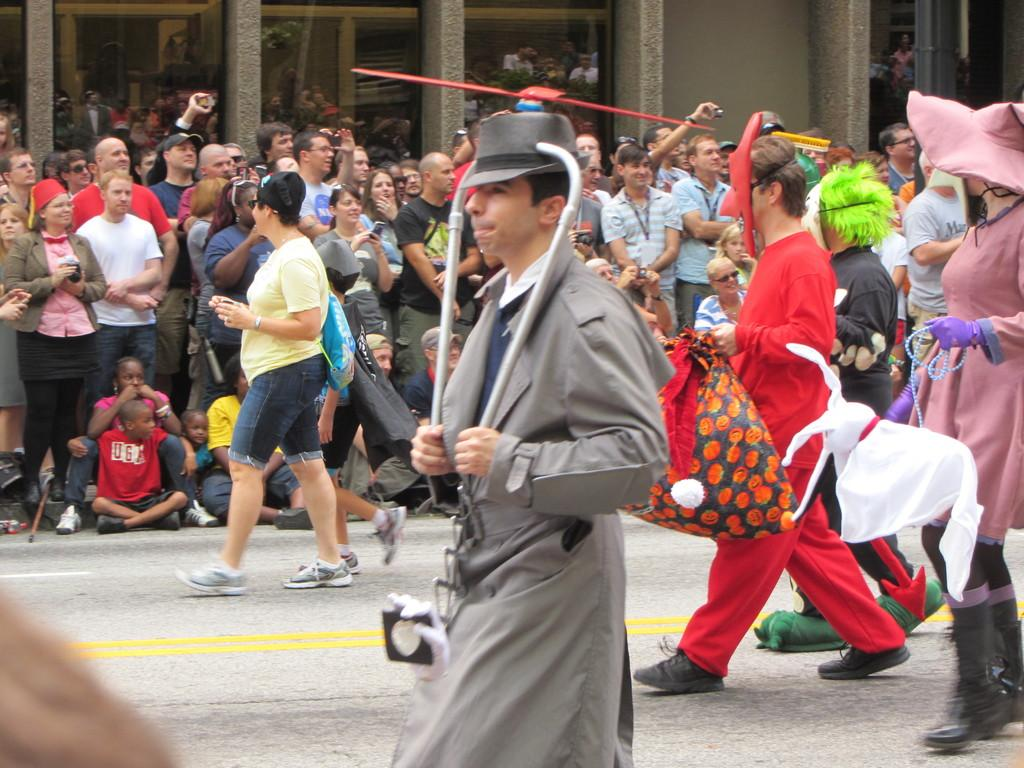What are the people in the image doing? The people in the image are walking on the road. What are the people wearing while walking on the road? The people are wearing different costumes and masks. Can you describe the people in the background of the image? The people in the background are spectators, and they are standing on the footpath. What type of trousers are the pancakes wearing in the image? There are no pancakes or trousers present in the image. What is the border between the people and the spectators in the image? There is no specific border mentioned in the image; it simply shows people walking on the road and spectators standing on the footpath. 